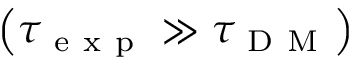<formula> <loc_0><loc_0><loc_500><loc_500>\left ( \tau _ { e x p } \gg \tau _ { D M } \right )</formula> 